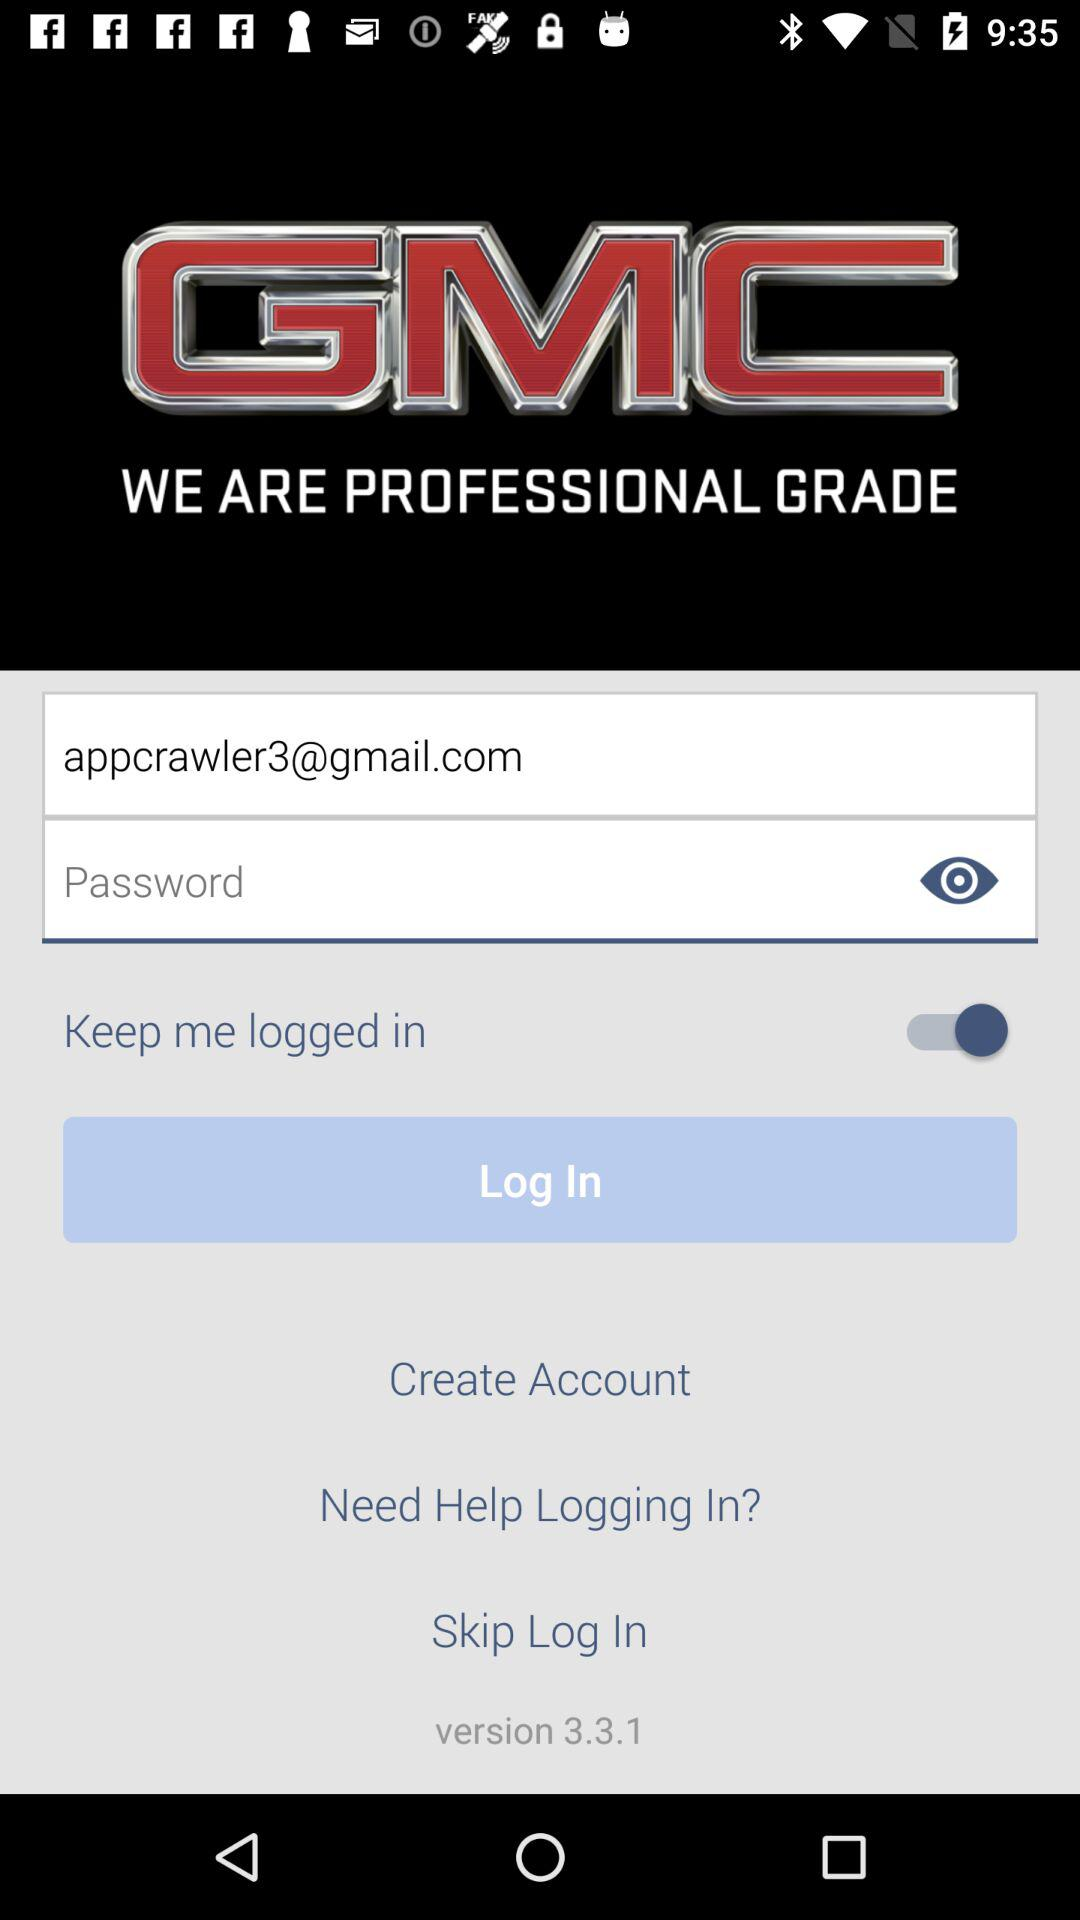What is the app name? The app name is "GMC". 